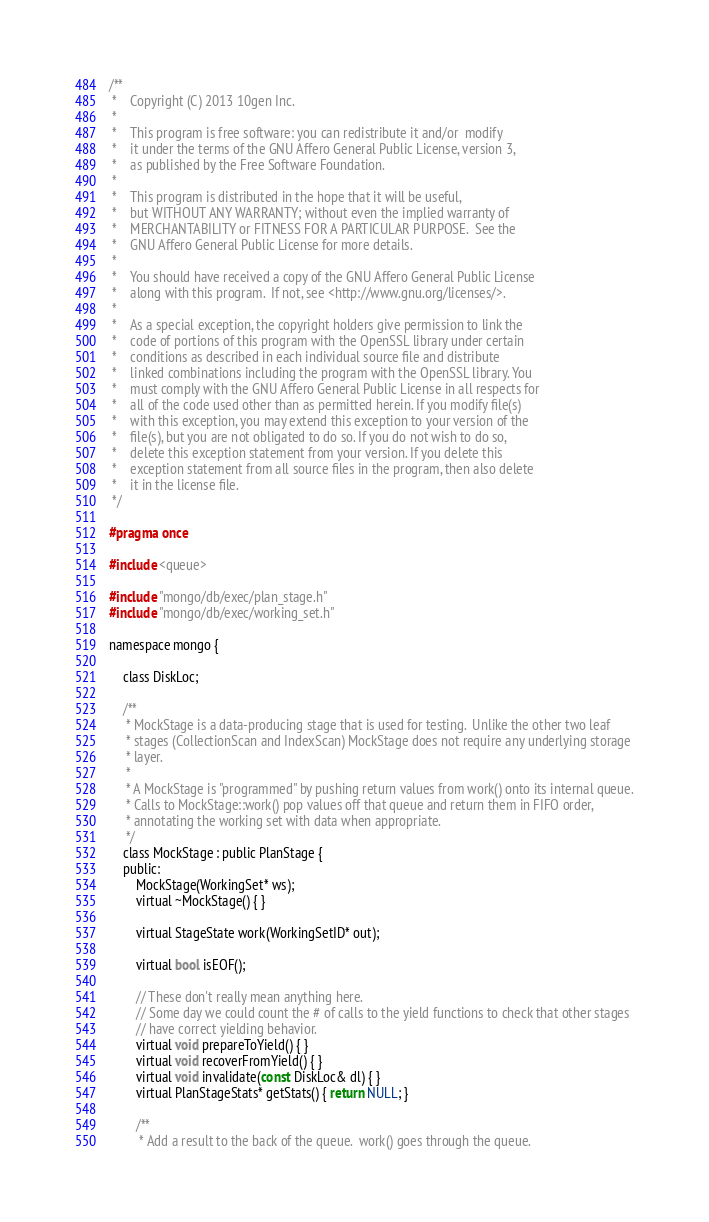<code> <loc_0><loc_0><loc_500><loc_500><_C_>/**
 *    Copyright (C) 2013 10gen Inc.
 *
 *    This program is free software: you can redistribute it and/or  modify
 *    it under the terms of the GNU Affero General Public License, version 3,
 *    as published by the Free Software Foundation.
 *
 *    This program is distributed in the hope that it will be useful,
 *    but WITHOUT ANY WARRANTY; without even the implied warranty of
 *    MERCHANTABILITY or FITNESS FOR A PARTICULAR PURPOSE.  See the
 *    GNU Affero General Public License for more details.
 *
 *    You should have received a copy of the GNU Affero General Public License
 *    along with this program.  If not, see <http://www.gnu.org/licenses/>.
 *
 *    As a special exception, the copyright holders give permission to link the
 *    code of portions of this program with the OpenSSL library under certain
 *    conditions as described in each individual source file and distribute
 *    linked combinations including the program with the OpenSSL library. You
 *    must comply with the GNU Affero General Public License in all respects for
 *    all of the code used other than as permitted herein. If you modify file(s)
 *    with this exception, you may extend this exception to your version of the
 *    file(s), but you are not obligated to do so. If you do not wish to do so,
 *    delete this exception statement from your version. If you delete this
 *    exception statement from all source files in the program, then also delete
 *    it in the license file.
 */

#pragma once

#include <queue>

#include "mongo/db/exec/plan_stage.h"
#include "mongo/db/exec/working_set.h"

namespace mongo {

    class DiskLoc;

    /**
     * MockStage is a data-producing stage that is used for testing.  Unlike the other two leaf
     * stages (CollectionScan and IndexScan) MockStage does not require any underlying storage
     * layer.
     *
     * A MockStage is "programmed" by pushing return values from work() onto its internal queue.
     * Calls to MockStage::work() pop values off that queue and return them in FIFO order,
     * annotating the working set with data when appropriate.
     */
    class MockStage : public PlanStage {
    public:
        MockStage(WorkingSet* ws);
        virtual ~MockStage() { }

        virtual StageState work(WorkingSetID* out);

        virtual bool isEOF();

        // These don't really mean anything here.
        // Some day we could count the # of calls to the yield functions to check that other stages
        // have correct yielding behavior.
        virtual void prepareToYield() { }
        virtual void recoverFromYield() { }
        virtual void invalidate(const DiskLoc& dl) { }
        virtual PlanStageStats* getStats() { return NULL; }

        /**
         * Add a result to the back of the queue.  work() goes through the queue.</code> 